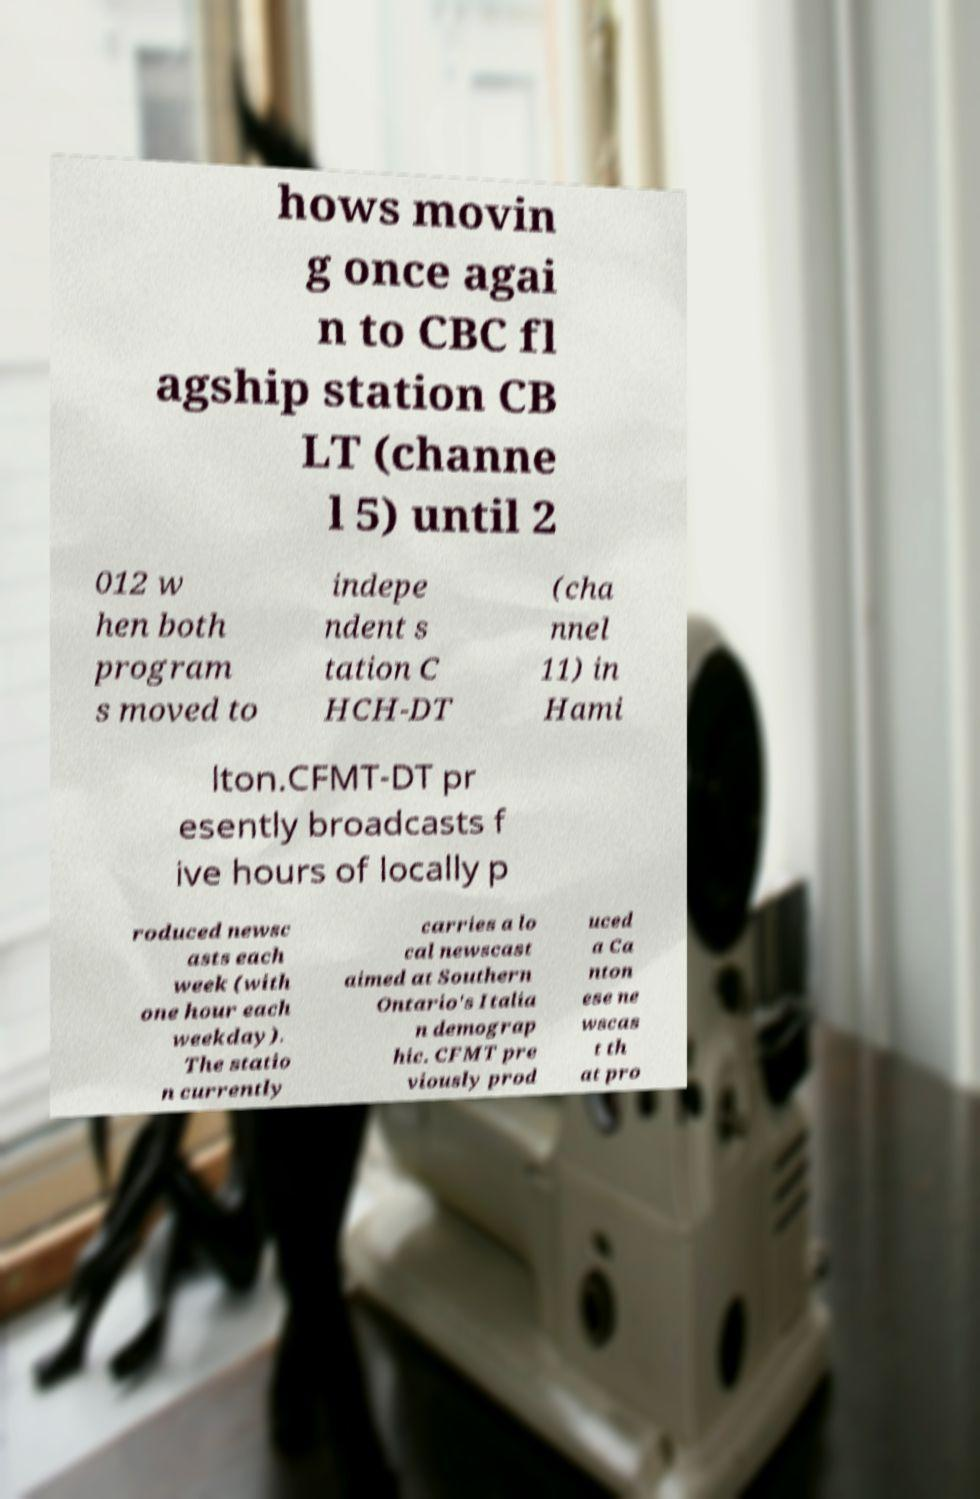Could you extract and type out the text from this image? hows movin g once agai n to CBC fl agship station CB LT (channe l 5) until 2 012 w hen both program s moved to indepe ndent s tation C HCH-DT (cha nnel 11) in Hami lton.CFMT-DT pr esently broadcasts f ive hours of locally p roduced newsc asts each week (with one hour each weekday). The statio n currently carries a lo cal newscast aimed at Southern Ontario's Italia n demograp hic. CFMT pre viously prod uced a Ca nton ese ne wscas t th at pro 